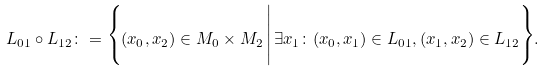<formula> <loc_0><loc_0><loc_500><loc_500>L _ { 0 1 } \circ L _ { 1 2 } \colon = \Big \{ ( x _ { 0 } , x _ { 2 } ) \in M _ { 0 } \times M _ { 2 } \, \Big | \, \exists x _ { 1 } \colon ( x _ { 0 } , x _ { 1 } ) \in L _ { 0 1 } , ( x _ { 1 } , x _ { 2 } ) \in L _ { 1 2 } \Big \} .</formula> 